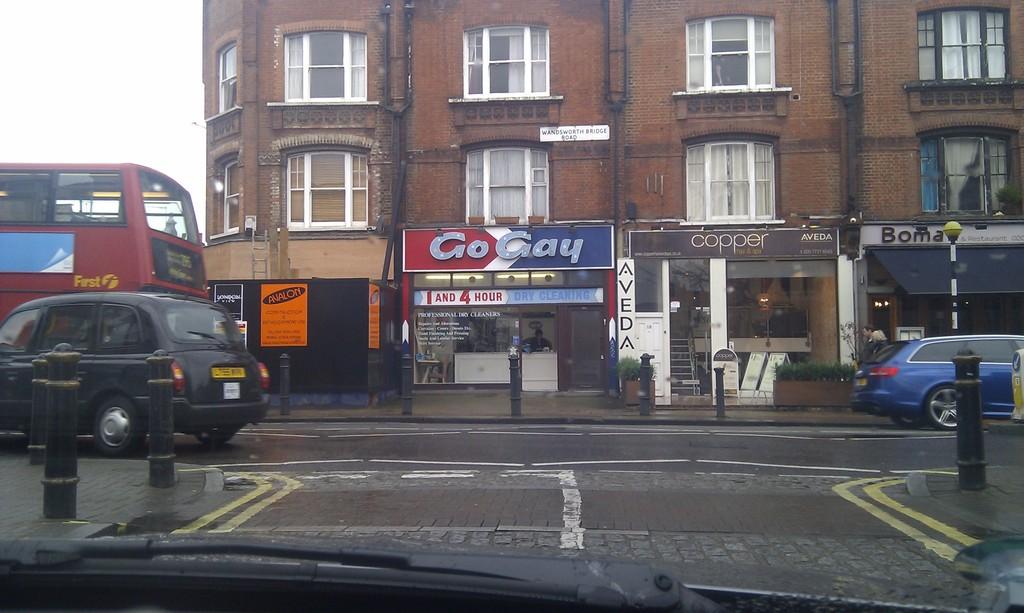What is the name of the shop with the brown frontage in the middle?
Your response must be concise. Copper. What is the name of the shop in the middle of the picture?
Your answer should be compact. Go gay. 